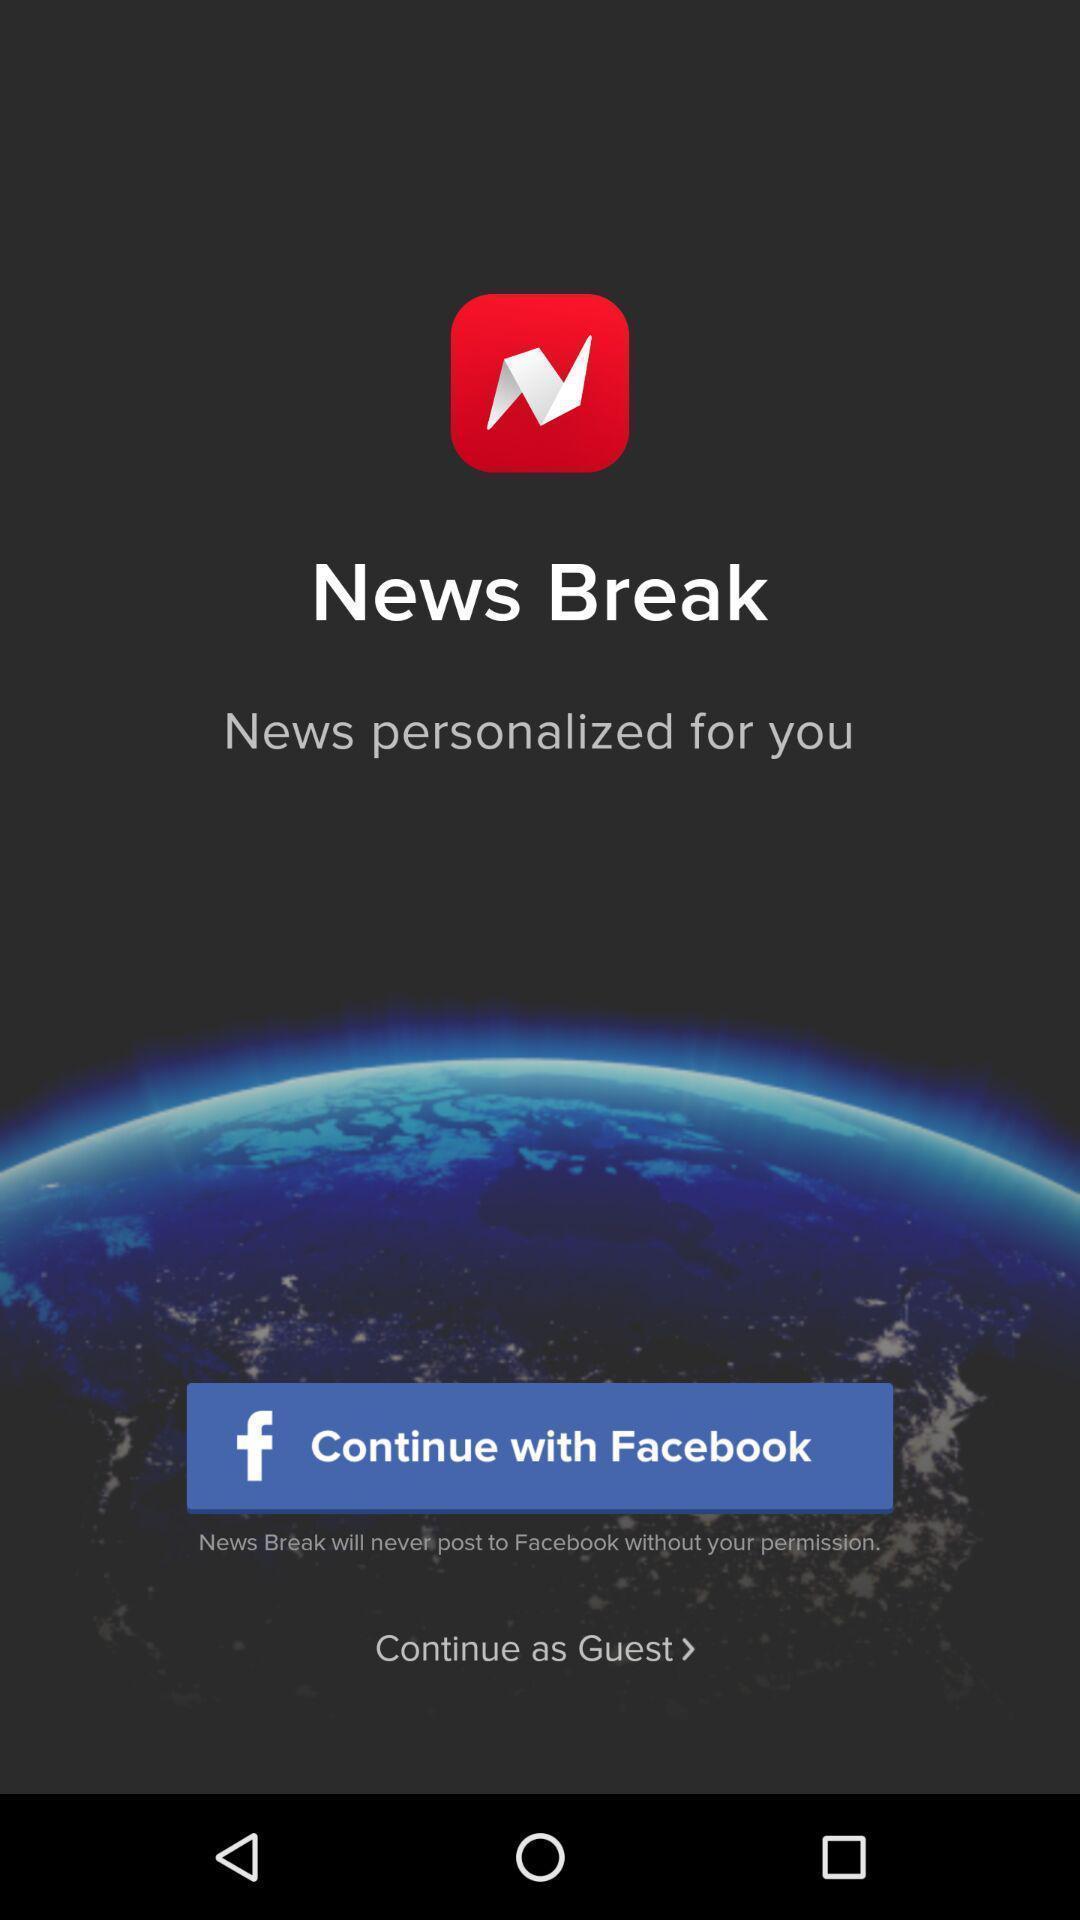Provide a textual representation of this image. Welcome page. 